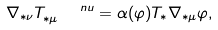<formula> <loc_0><loc_0><loc_500><loc_500>\nabla _ { * \nu } T _ { * \mu } ^ { \quad n u } = \alpha ( \varphi ) T _ { * } \nabla _ { * \mu } \varphi ,</formula> 